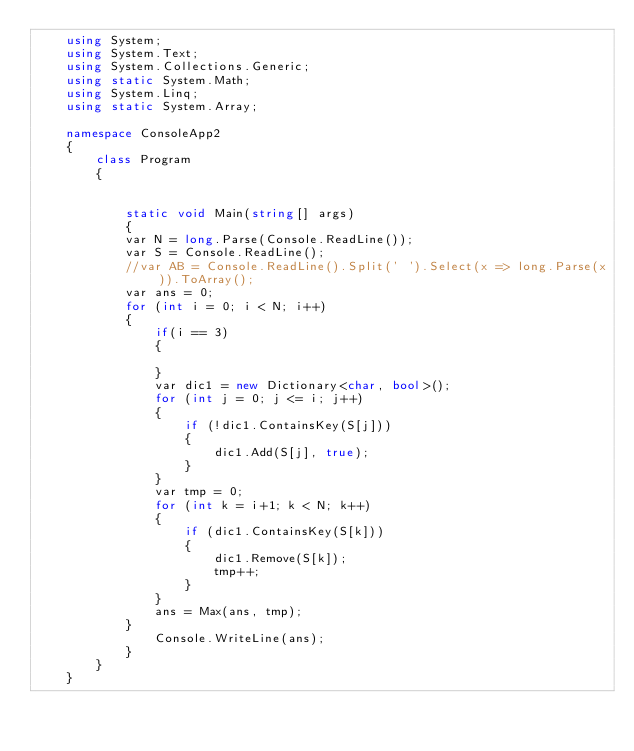<code> <loc_0><loc_0><loc_500><loc_500><_C#_>    using System;
    using System.Text;
    using System.Collections.Generic;
    using static System.Math;
    using System.Linq;
    using static System.Array;

    namespace ConsoleApp2
    {
        class Program
        {


            static void Main(string[] args)
            {
            var N = long.Parse(Console.ReadLine());
            var S = Console.ReadLine();
            //var AB = Console.ReadLine().Split(' ').Select(x => long.Parse(x)).ToArray();
            var ans = 0;
            for (int i = 0; i < N; i++)
            {
                if(i == 3)
                {

                }
                var dic1 = new Dictionary<char, bool>();
                for (int j = 0; j <= i; j++)
                {
                    if (!dic1.ContainsKey(S[j]))
                    {
                        dic1.Add(S[j], true);
                    }
                }
                var tmp = 0;
                for (int k = i+1; k < N; k++)
                {
                    if (dic1.ContainsKey(S[k]))
                    {
                        dic1.Remove(S[k]);
                        tmp++;
                    }
                }
                ans = Max(ans, tmp);
            }
                Console.WriteLine(ans);
            }
        }
    }
</code> 